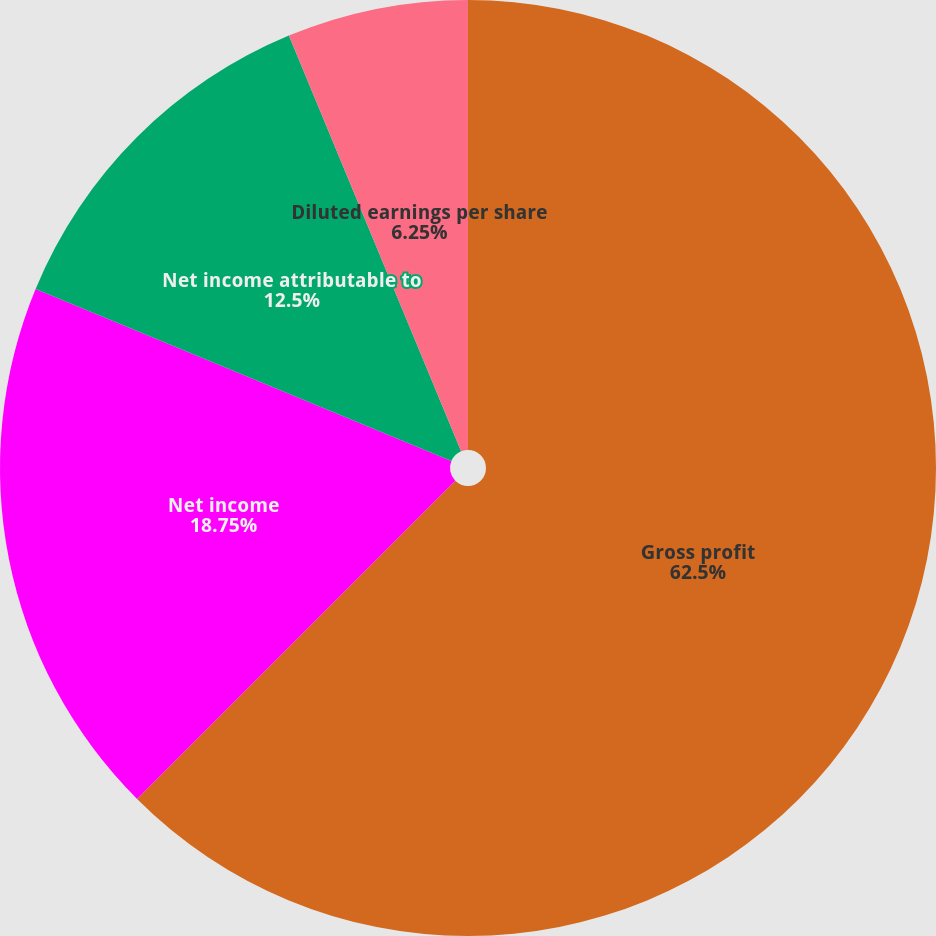Convert chart. <chart><loc_0><loc_0><loc_500><loc_500><pie_chart><fcel>Gross profit<fcel>Net income<fcel>Net income attributable to<fcel>Basic earnings per share<fcel>Diluted earnings per share<nl><fcel>62.5%<fcel>18.75%<fcel>12.5%<fcel>0.0%<fcel>6.25%<nl></chart> 